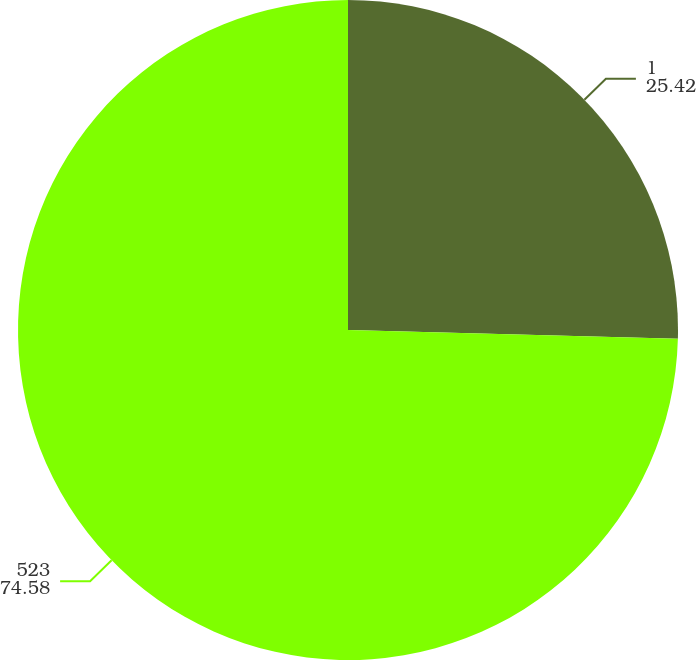Convert chart. <chart><loc_0><loc_0><loc_500><loc_500><pie_chart><fcel>1<fcel>523<nl><fcel>25.42%<fcel>74.58%<nl></chart> 